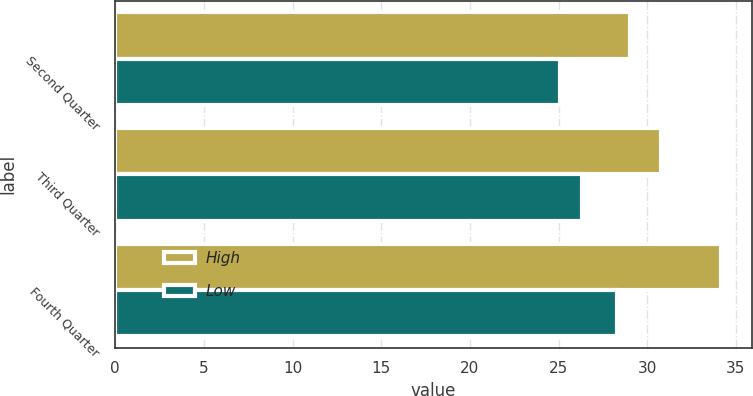<chart> <loc_0><loc_0><loc_500><loc_500><stacked_bar_chart><ecel><fcel>Second Quarter<fcel>Third Quarter<fcel>Fourth Quarter<nl><fcel>High<fcel>29<fcel>30.8<fcel>34.18<nl><fcel>Low<fcel>25.06<fcel>26.31<fcel>28.28<nl></chart> 